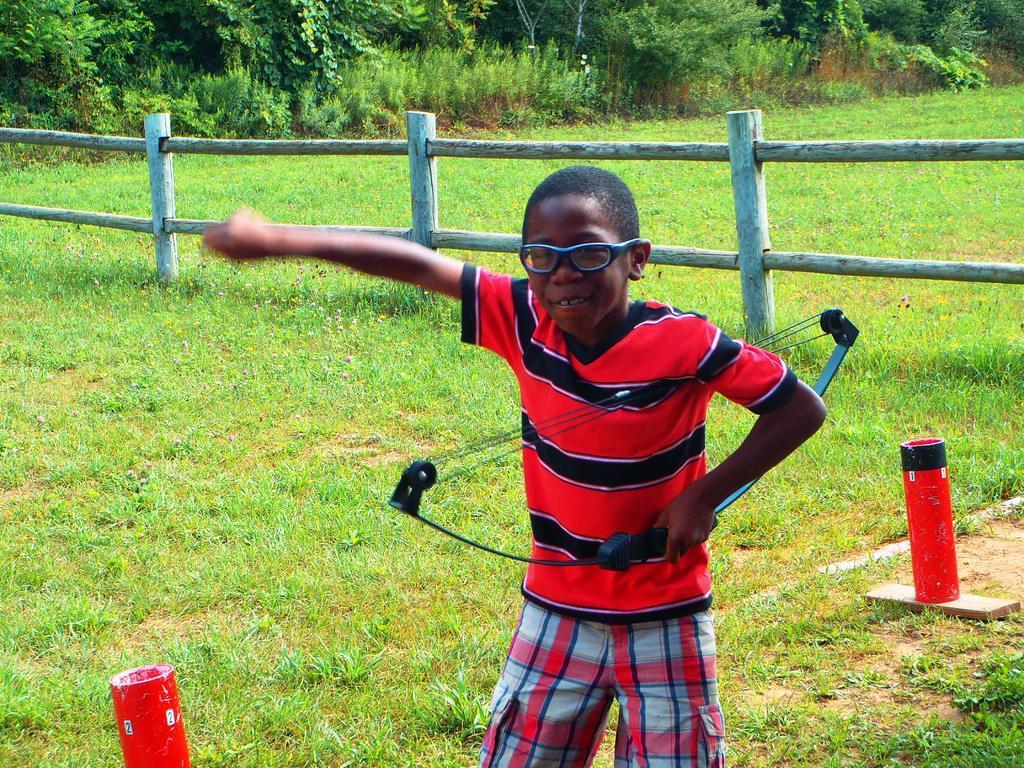Please provide a concise description of this image. In front of the image there is a person holding some object. At the bottom of the image there are some objects on the grass. There is a wooden fence. In the background of the image there are trees. 